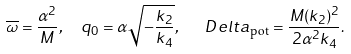Convert formula to latex. <formula><loc_0><loc_0><loc_500><loc_500>\overline { \omega } = \frac { \alpha ^ { 2 } } { M } , \ \ q _ { 0 } = \alpha \sqrt { - \frac { k _ { 2 } } { k _ { 4 } } } , \ \ \ D e l t a _ { \text {pot} } = \frac { M ( k _ { 2 } ) ^ { 2 } } { 2 \alpha ^ { 2 } k _ { 4 } } .</formula> 